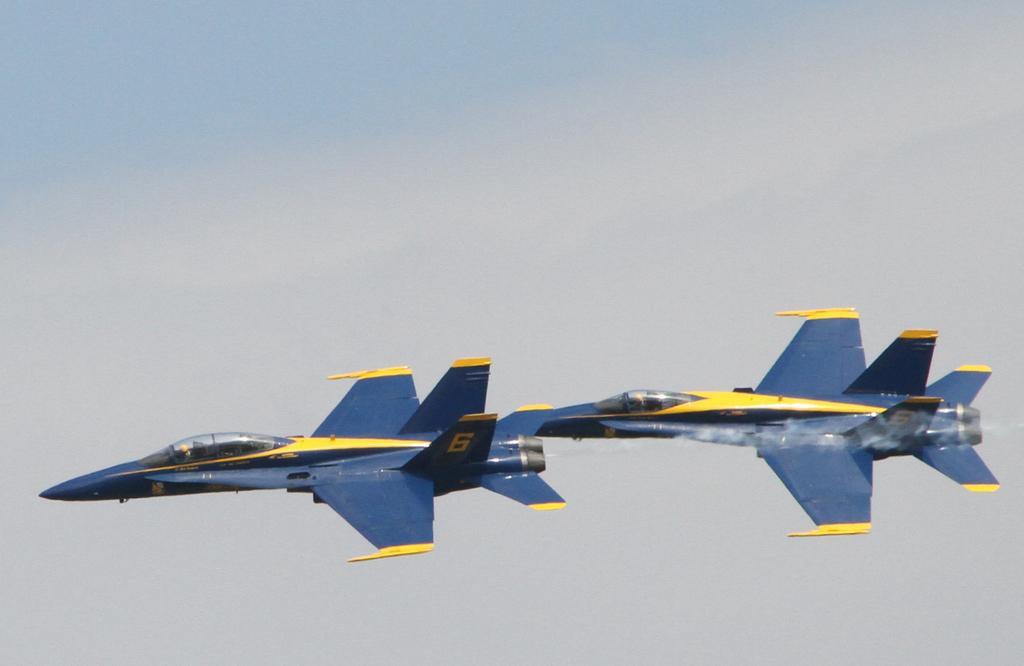<image>
Share a concise interpretation of the image provided. Two planes with the number 6 on their wing. 